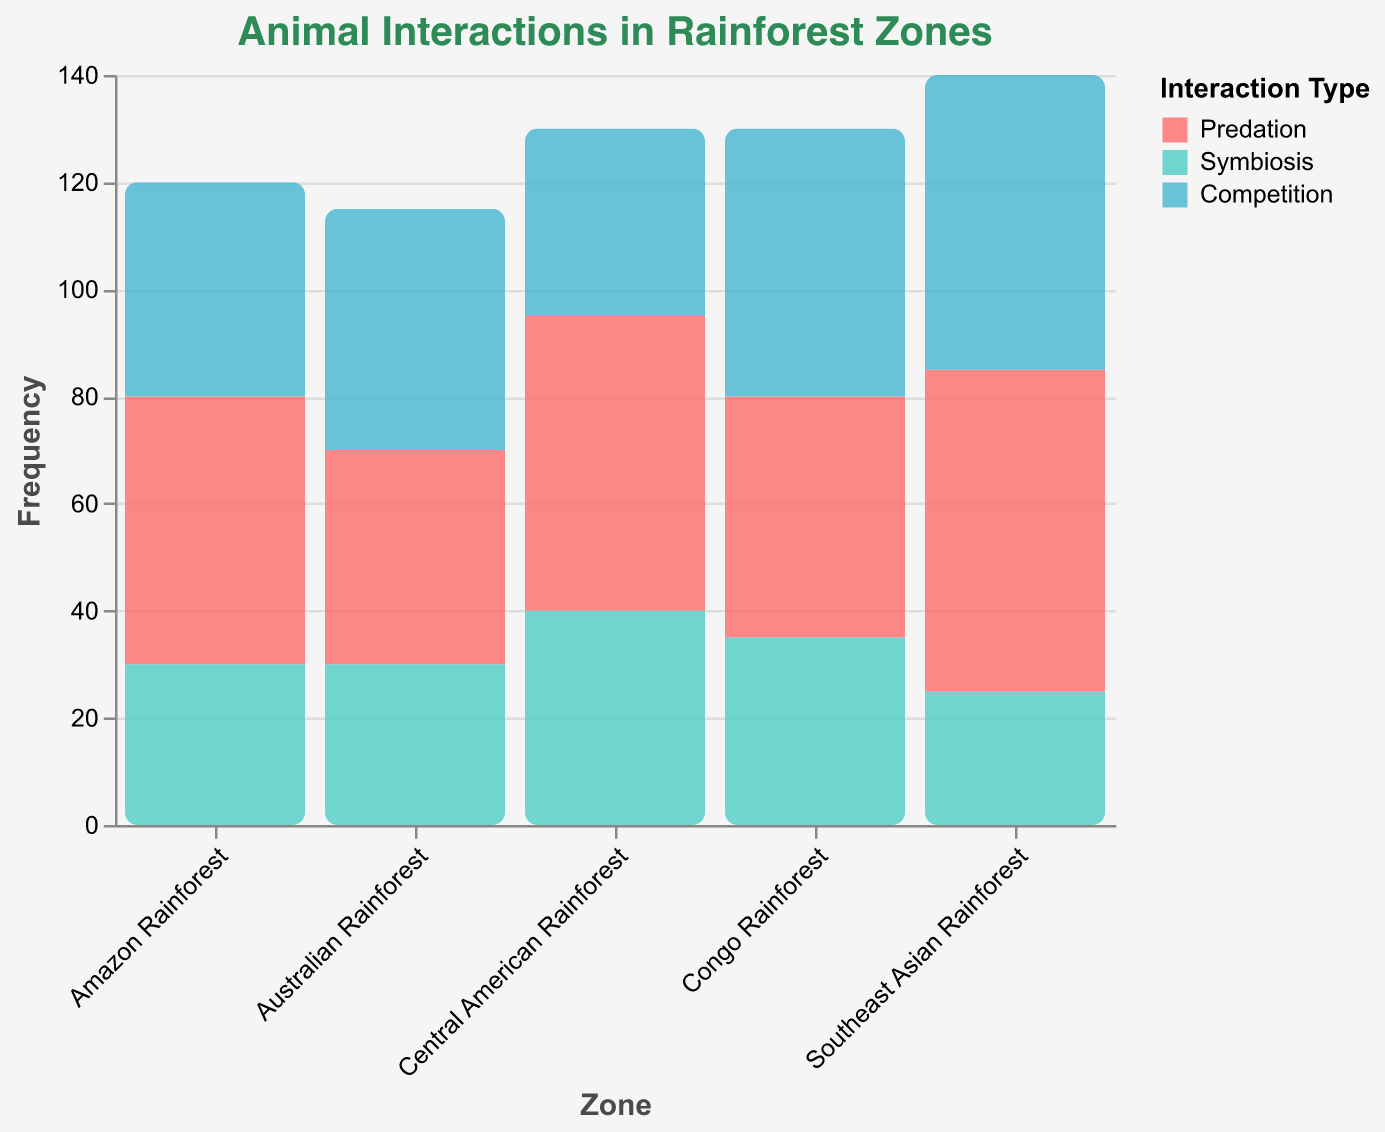What is the title of the plot? The title of the plot is displayed at the top. It reads "Animal Interactions in Rainforest Zones".
Answer: Animal Interactions in Rainforest Zones Which rainforest zone has the highest frequency of predation? By looking at the height of the bars corresponding to "Predation" for each rainforest zone, the Southeast Asian Rainforest has the highest bar indicating a frequency of 60.
Answer: Southeast Asian Rainforest How many different types of interactions are represented in the plot? The legend shows three different colors, each representing an interaction type: Predation, Symbiosis, and Competition.
Answer: Three What is the total frequency of interactions observed in the Australian Rainforest? Sum the frequencies of each interaction type in the Australian Rainforest: 40 (Predation) + 30 (Symbiosis) + 45 (Competition) = 115.
Answer: 115 Compare the frequency of competition interactions between the Congo Rainforest and Central American Rainforest. Which one is higher? The frequency for the Congo Rainforest is 50 while for the Central American Rainforest, it is 35. Since 50 is greater than 35, the Congo Rainforest has a higher frequency of competition interactions.
Answer: Congo Rainforest Which interaction type has the highest overall frequency in all rainforest zones combined? Sum the frequencies of all zones for each interaction type: 
- Predation: 50 + 45 + 60 + 55 + 40 = 250
- Symbiosis: 30 + 35 + 25 + 40 + 30 = 160
- Competition: 40 + 50 + 55 + 35 + 45 = 225 
Predation has the highest overall frequency, which is 250.
Answer: Predation What is the average frequency of symbiosis interactions across all rainforest zones? Sum the frequencies of symbiosis interactions (30 + 35 + 25 + 40 + 30 = 160) and divide by the number of zones (5). The average is 160/5 = 32.
Answer: 32 Is there a rainforest zone where the frequency of symbiotic interactions exceeds the frequency of competitive interactions? For each rainforest zone compare the symbiotic interactions with competitive interactions:
- Amazon Rainforest: 30 (Symbiosis) vs 40 (Competition)
- Congo Rainforest: 35 (Symbiosis) vs 50 (Competition)
- Southeast Asian Rainforest: 25 (Symbiosis) vs 55 (Competition)
- Central American Rainforest: 40 (Symbiosis) vs 35 (Competition)
- Australian Rainforest: 30 (Symbiosis) vs 45 (Competition)
Only the Central American Rainforest has a higher frequency of symbiotic interactions (40) compared to competition (35).
Answer: Central American Rainforest 